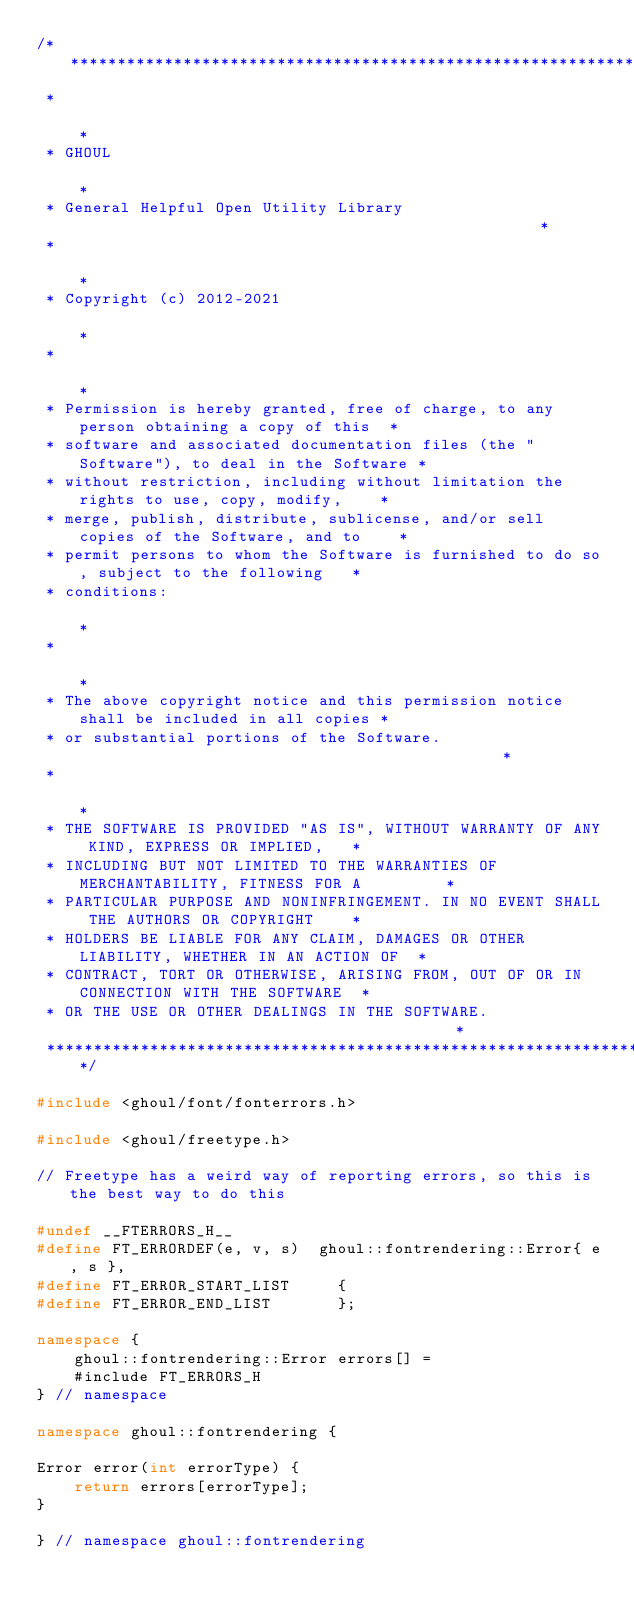Convert code to text. <code><loc_0><loc_0><loc_500><loc_500><_C++_>/*****************************************************************************************
 *                                                                                       *
 * GHOUL                                                                                 *
 * General Helpful Open Utility Library                                                  *
 *                                                                                       *
 * Copyright (c) 2012-2021                                                               *
 *                                                                                       *
 * Permission is hereby granted, free of charge, to any person obtaining a copy of this  *
 * software and associated documentation files (the "Software"), to deal in the Software *
 * without restriction, including without limitation the rights to use, copy, modify,    *
 * merge, publish, distribute, sublicense, and/or sell copies of the Software, and to    *
 * permit persons to whom the Software is furnished to do so, subject to the following   *
 * conditions:                                                                           *
 *                                                                                       *
 * The above copyright notice and this permission notice shall be included in all copies *
 * or substantial portions of the Software.                                              *
 *                                                                                       *
 * THE SOFTWARE IS PROVIDED "AS IS", WITHOUT WARRANTY OF ANY KIND, EXPRESS OR IMPLIED,   *
 * INCLUDING BUT NOT LIMITED TO THE WARRANTIES OF MERCHANTABILITY, FITNESS FOR A         *
 * PARTICULAR PURPOSE AND NONINFRINGEMENT. IN NO EVENT SHALL THE AUTHORS OR COPYRIGHT    *
 * HOLDERS BE LIABLE FOR ANY CLAIM, DAMAGES OR OTHER LIABILITY, WHETHER IN AN ACTION OF  *
 * CONTRACT, TORT OR OTHERWISE, ARISING FROM, OUT OF OR IN CONNECTION WITH THE SOFTWARE  *
 * OR THE USE OR OTHER DEALINGS IN THE SOFTWARE.                                         *
 ****************************************************************************************/

#include <ghoul/font/fonterrors.h>

#include <ghoul/freetype.h>

// Freetype has a weird way of reporting errors, so this is the best way to do this

#undef __FTERRORS_H__
#define FT_ERRORDEF(e, v, s)  ghoul::fontrendering::Error{ e, s },
#define FT_ERROR_START_LIST     {
#define FT_ERROR_END_LIST       };

namespace {
    ghoul::fontrendering::Error errors[] =
    #include FT_ERRORS_H
} // namespace

namespace ghoul::fontrendering {

Error error(int errorType) {
    return errors[errorType];
}

} // namespace ghoul::fontrendering
</code> 